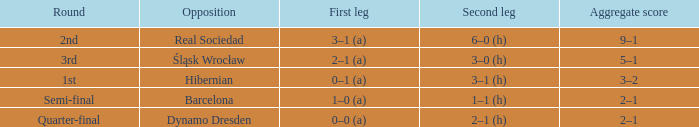What was the first leg of the semi-final? 1–0 (a). 